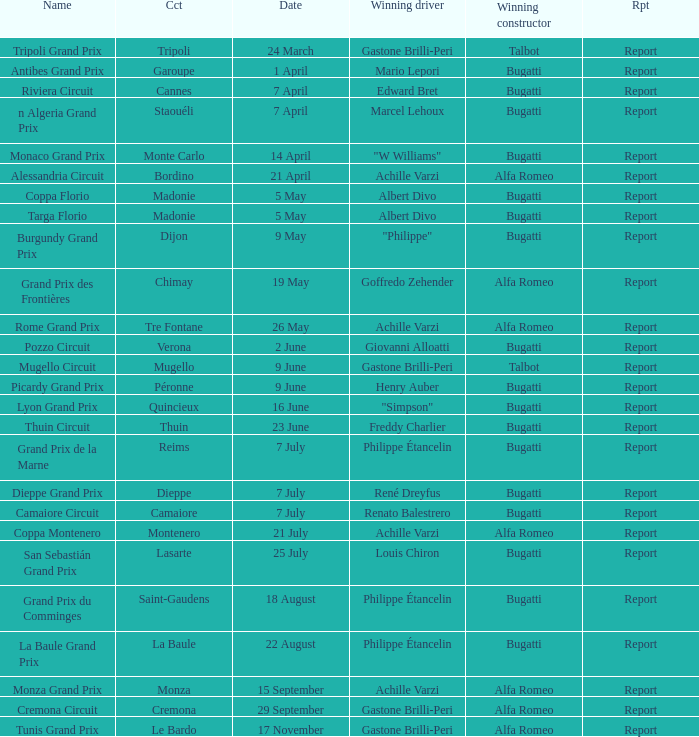Would you mind parsing the complete table? {'header': ['Name', 'Cct', 'Date', 'Winning driver', 'Winning constructor', 'Rpt'], 'rows': [['Tripoli Grand Prix', 'Tripoli', '24 March', 'Gastone Brilli-Peri', 'Talbot', 'Report'], ['Antibes Grand Prix', 'Garoupe', '1 April', 'Mario Lepori', 'Bugatti', 'Report'], ['Riviera Circuit', 'Cannes', '7 April', 'Edward Bret', 'Bugatti', 'Report'], ['n Algeria Grand Prix', 'Staouéli', '7 April', 'Marcel Lehoux', 'Bugatti', 'Report'], ['Monaco Grand Prix', 'Monte Carlo', '14 April', '"W Williams"', 'Bugatti', 'Report'], ['Alessandria Circuit', 'Bordino', '21 April', 'Achille Varzi', 'Alfa Romeo', 'Report'], ['Coppa Florio', 'Madonie', '5 May', 'Albert Divo', 'Bugatti', 'Report'], ['Targa Florio', 'Madonie', '5 May', 'Albert Divo', 'Bugatti', 'Report'], ['Burgundy Grand Prix', 'Dijon', '9 May', '"Philippe"', 'Bugatti', 'Report'], ['Grand Prix des Frontières', 'Chimay', '19 May', 'Goffredo Zehender', 'Alfa Romeo', 'Report'], ['Rome Grand Prix', 'Tre Fontane', '26 May', 'Achille Varzi', 'Alfa Romeo', 'Report'], ['Pozzo Circuit', 'Verona', '2 June', 'Giovanni Alloatti', 'Bugatti', 'Report'], ['Mugello Circuit', 'Mugello', '9 June', 'Gastone Brilli-Peri', 'Talbot', 'Report'], ['Picardy Grand Prix', 'Péronne', '9 June', 'Henry Auber', 'Bugatti', 'Report'], ['Lyon Grand Prix', 'Quincieux', '16 June', '"Simpson"', 'Bugatti', 'Report'], ['Thuin Circuit', 'Thuin', '23 June', 'Freddy Charlier', 'Bugatti', 'Report'], ['Grand Prix de la Marne', 'Reims', '7 July', 'Philippe Étancelin', 'Bugatti', 'Report'], ['Dieppe Grand Prix', 'Dieppe', '7 July', 'René Dreyfus', 'Bugatti', 'Report'], ['Camaiore Circuit', 'Camaiore', '7 July', 'Renato Balestrero', 'Bugatti', 'Report'], ['Coppa Montenero', 'Montenero', '21 July', 'Achille Varzi', 'Alfa Romeo', 'Report'], ['San Sebastián Grand Prix', 'Lasarte', '25 July', 'Louis Chiron', 'Bugatti', 'Report'], ['Grand Prix du Comminges', 'Saint-Gaudens', '18 August', 'Philippe Étancelin', 'Bugatti', 'Report'], ['La Baule Grand Prix', 'La Baule', '22 August', 'Philippe Étancelin', 'Bugatti', 'Report'], ['Monza Grand Prix', 'Monza', '15 September', 'Achille Varzi', 'Alfa Romeo', 'Report'], ['Cremona Circuit', 'Cremona', '29 September', 'Gastone Brilli-Peri', 'Alfa Romeo', 'Report'], ['Tunis Grand Prix', 'Le Bardo', '17 November', 'Gastone Brilli-Peri', 'Alfa Romeo', 'Report']]} What Date has a Name of thuin circuit? 23 June. 